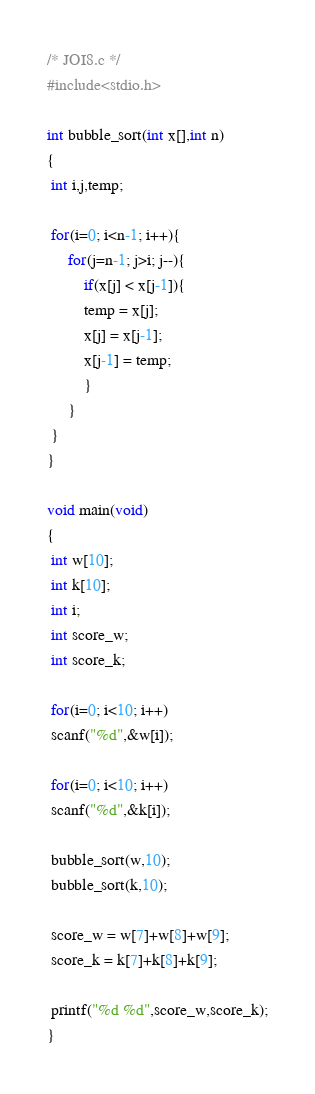Convert code to text. <code><loc_0><loc_0><loc_500><loc_500><_C_>/* JOI8.c */
#include<stdio.h>

int bubble_sort(int x[],int n)
{
 int i,j,temp;

 for(i=0; i<n-1; i++){
     for(j=n-1; j>i; j--){
         if(x[j] < x[j-1]){
         temp = x[j];
         x[j] = x[j-1];
         x[j-1] = temp;
         }
     }
 }
}

void main(void)
{
 int w[10];
 int k[10];
 int i;
 int score_w;
 int score_k;

 for(i=0; i<10; i++)
 scanf("%d",&w[i]);

 for(i=0; i<10; i++)
 scanf("%d",&k[i]); 

 bubble_sort(w,10);
 bubble_sort(k,10);

 score_w = w[7]+w[8]+w[9];
 score_k = k[7]+k[8]+k[9];

 printf("%d %d",score_w,score_k);
}</code> 